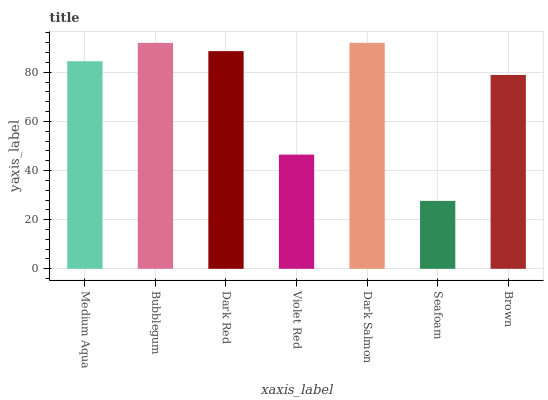Is Seafoam the minimum?
Answer yes or no. Yes. Is Dark Salmon the maximum?
Answer yes or no. Yes. Is Bubblegum the minimum?
Answer yes or no. No. Is Bubblegum the maximum?
Answer yes or no. No. Is Bubblegum greater than Medium Aqua?
Answer yes or no. Yes. Is Medium Aqua less than Bubblegum?
Answer yes or no. Yes. Is Medium Aqua greater than Bubblegum?
Answer yes or no. No. Is Bubblegum less than Medium Aqua?
Answer yes or no. No. Is Medium Aqua the high median?
Answer yes or no. Yes. Is Medium Aqua the low median?
Answer yes or no. Yes. Is Dark Red the high median?
Answer yes or no. No. Is Bubblegum the low median?
Answer yes or no. No. 